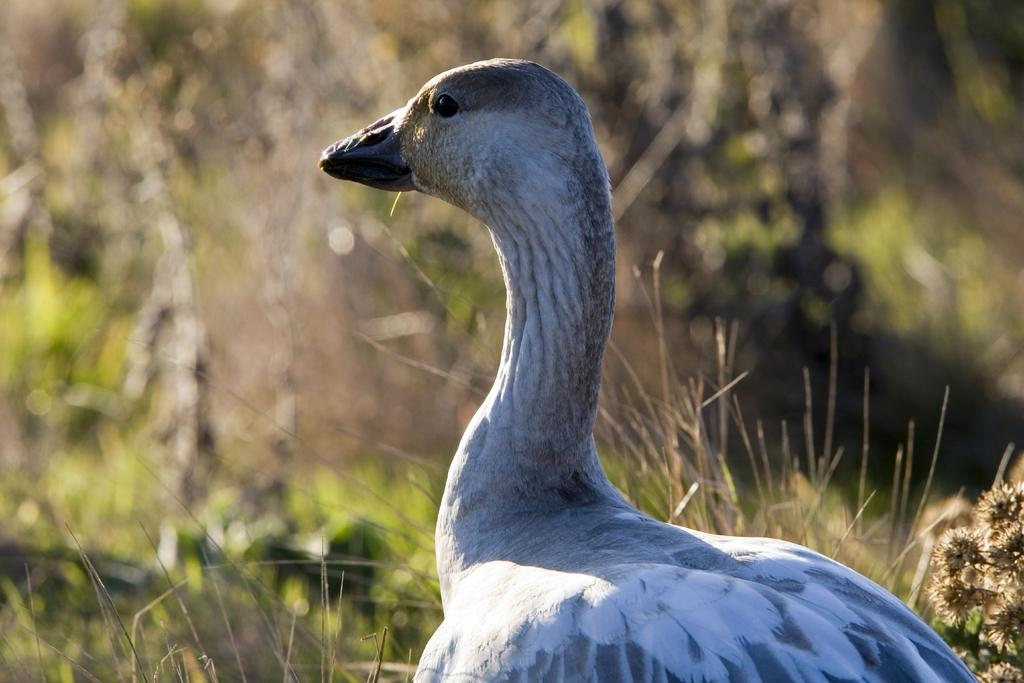What type of animal can be seen in the picture? There is a bird in the picture. How close is the bird in the image? The bird is in close view in the image. What can be observed about the background of the image? The background of the image is blurred. What type of vegetation is visible in the background? Grass and plants are visible in the background. Can you see a goldfish swimming in the background of the image? No, there is no goldfish present in the image. Is there a team of animals playing a game in the image? No, there is no team or game depicted in the image. 